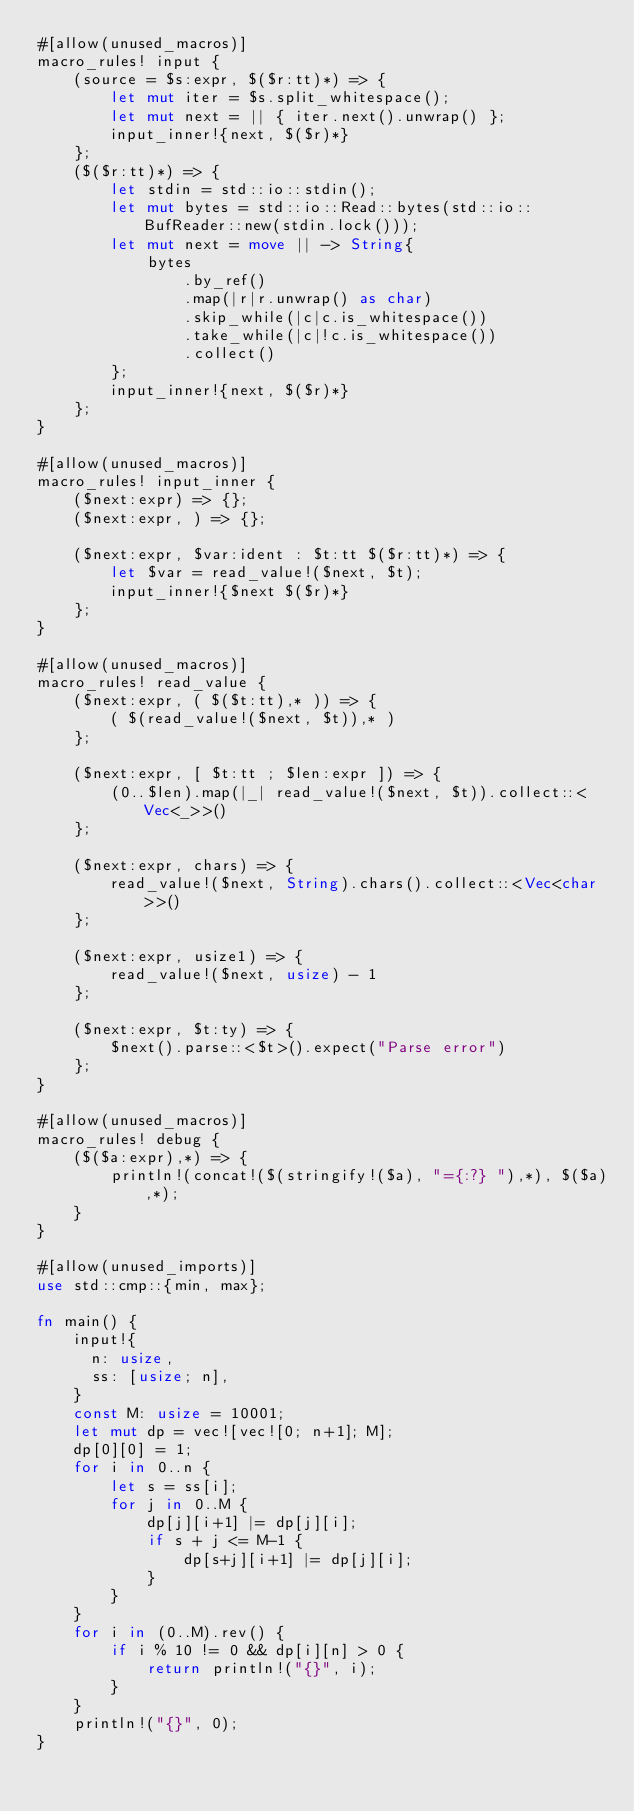Convert code to text. <code><loc_0><loc_0><loc_500><loc_500><_Rust_>#[allow(unused_macros)]
macro_rules! input {
    (source = $s:expr, $($r:tt)*) => {
        let mut iter = $s.split_whitespace();
        let mut next = || { iter.next().unwrap() };
        input_inner!{next, $($r)*}
    };
    ($($r:tt)*) => {
        let stdin = std::io::stdin();
        let mut bytes = std::io::Read::bytes(std::io::BufReader::new(stdin.lock()));
        let mut next = move || -> String{
            bytes
                .by_ref()
                .map(|r|r.unwrap() as char)
                .skip_while(|c|c.is_whitespace())
                .take_while(|c|!c.is_whitespace())
                .collect()
        };
        input_inner!{next, $($r)*}
    };
}

#[allow(unused_macros)]
macro_rules! input_inner {
    ($next:expr) => {};
    ($next:expr, ) => {};

    ($next:expr, $var:ident : $t:tt $($r:tt)*) => {
        let $var = read_value!($next, $t);
        input_inner!{$next $($r)*}
    };
}

#[allow(unused_macros)]
macro_rules! read_value {
    ($next:expr, ( $($t:tt),* )) => {
        ( $(read_value!($next, $t)),* )
    };

    ($next:expr, [ $t:tt ; $len:expr ]) => {
        (0..$len).map(|_| read_value!($next, $t)).collect::<Vec<_>>()
    };

    ($next:expr, chars) => {
        read_value!($next, String).chars().collect::<Vec<char>>()
    };

    ($next:expr, usize1) => {
        read_value!($next, usize) - 1
    };

    ($next:expr, $t:ty) => {
        $next().parse::<$t>().expect("Parse error")
    };
}

#[allow(unused_macros)]
macro_rules! debug {
    ($($a:expr),*) => {
        println!(concat!($(stringify!($a), "={:?} "),*), $($a),*);
    }
}

#[allow(unused_imports)]
use std::cmp::{min, max};

fn main() {
    input!{
      n: usize,
      ss: [usize; n],
    }
    const M: usize = 10001;
    let mut dp = vec![vec![0; n+1]; M];
    dp[0][0] = 1;
    for i in 0..n {
        let s = ss[i];
        for j in 0..M {
            dp[j][i+1] |= dp[j][i];
            if s + j <= M-1 {
                dp[s+j][i+1] |= dp[j][i];
            }
        }
    }
    for i in (0..M).rev() {
        if i % 10 != 0 && dp[i][n] > 0 {
            return println!("{}", i);
        }
    }
    println!("{}", 0);
}
</code> 